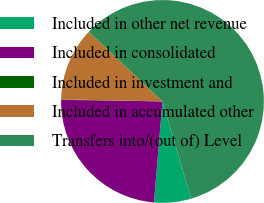Convert chart to OTSL. <chart><loc_0><loc_0><loc_500><loc_500><pie_chart><fcel>Included in other net revenue<fcel>Included in consolidated<fcel>Included in investment and<fcel>Included in accumulated other<fcel>Transfers into/(out of) Level<nl><fcel>5.9%<fcel>23.91%<fcel>0.07%<fcel>11.73%<fcel>58.38%<nl></chart> 